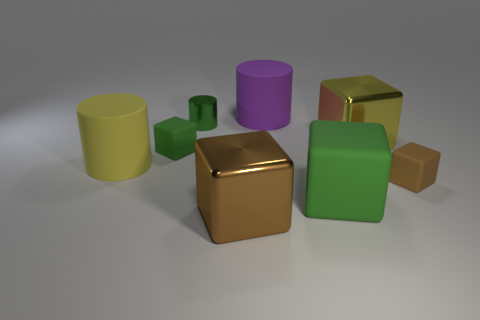What is the color of the small cylinder that is made of the same material as the big brown thing? green 